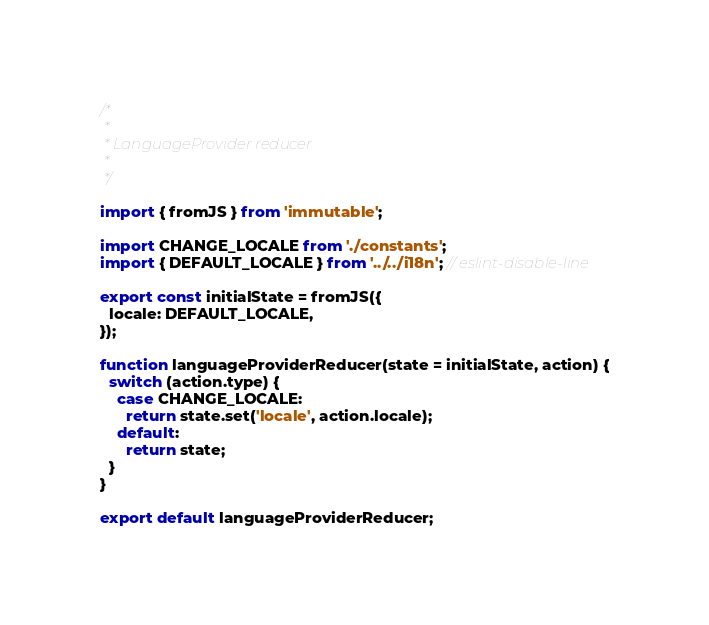<code> <loc_0><loc_0><loc_500><loc_500><_JavaScript_>/*
 *
 * LanguageProvider reducer
 *
 */

import { fromJS } from 'immutable';

import CHANGE_LOCALE from './constants';
import { DEFAULT_LOCALE } from '../../i18n'; // eslint-disable-line

export const initialState = fromJS({
  locale: DEFAULT_LOCALE,
});

function languageProviderReducer(state = initialState, action) {
  switch (action.type) {
    case CHANGE_LOCALE:
      return state.set('locale', action.locale);
    default:
      return state;
  }
}

export default languageProviderReducer;
</code> 